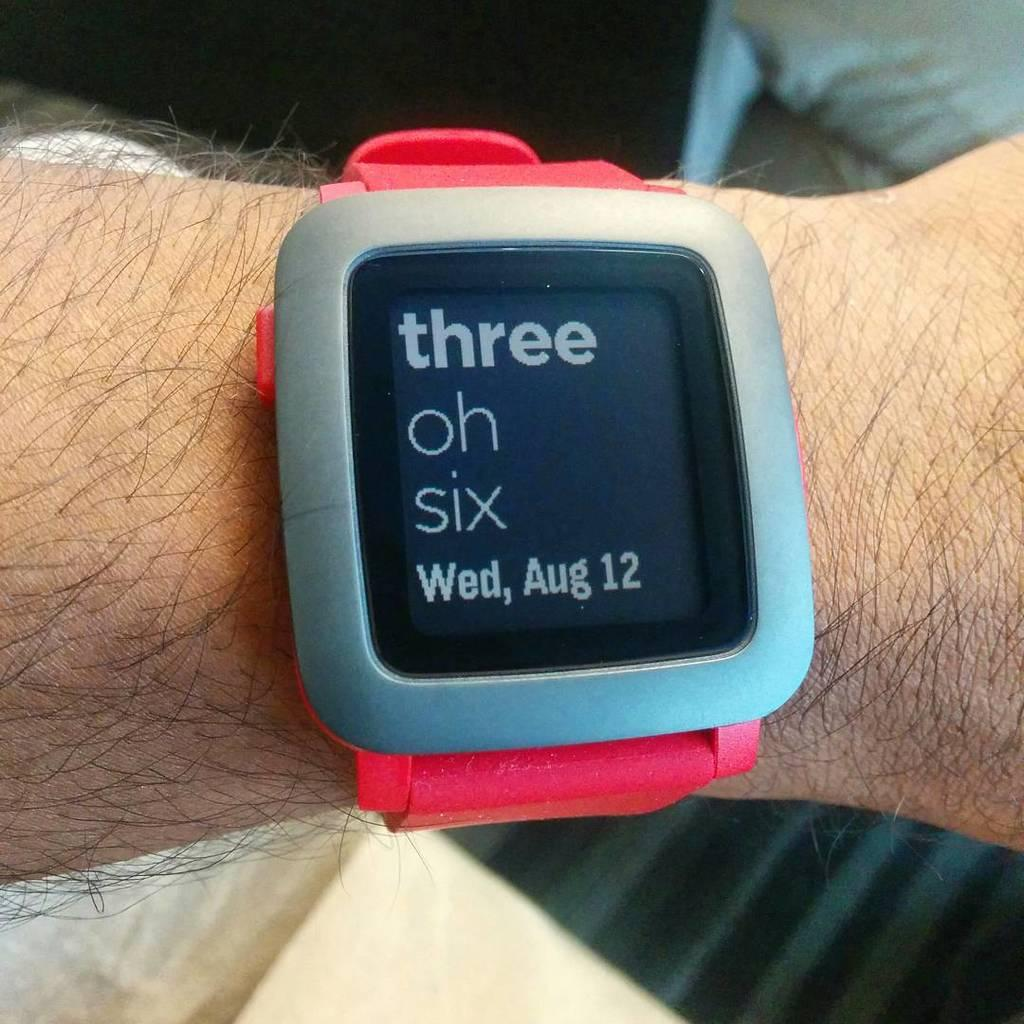<image>
Summarize the visual content of the image. A digital smartwatch has the words Three oh six displayed on its screen. 